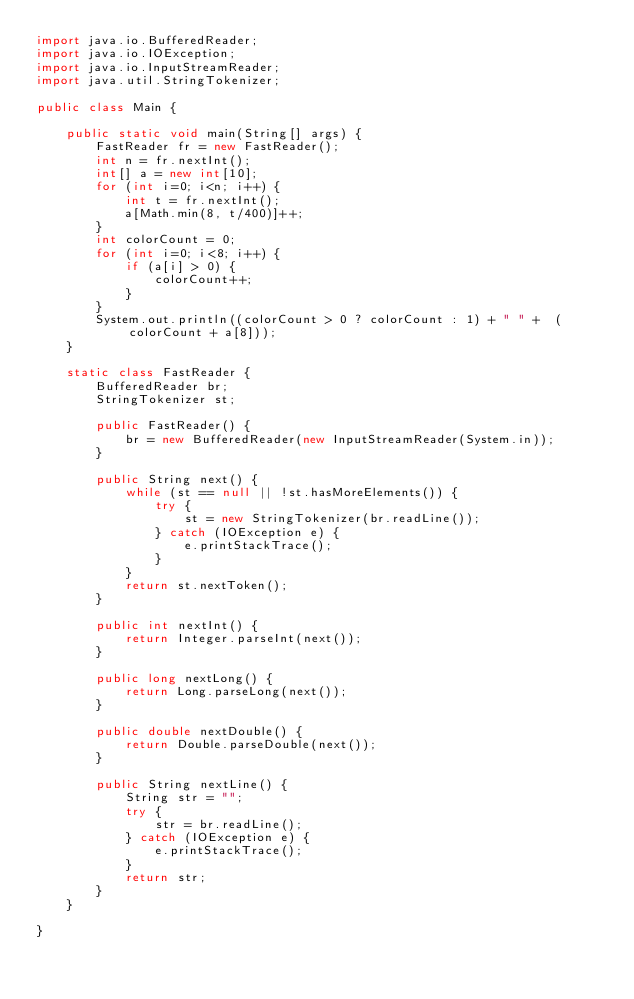<code> <loc_0><loc_0><loc_500><loc_500><_Java_>import java.io.BufferedReader;
import java.io.IOException;
import java.io.InputStreamReader;
import java.util.StringTokenizer;

public class Main {

	public static void main(String[] args) {
		FastReader fr = new FastReader();
		int n = fr.nextInt();
		int[] a = new int[10];
		for (int i=0; i<n; i++) {
			int t = fr.nextInt();
			a[Math.min(8, t/400)]++;
		}
		int colorCount = 0;
		for (int i=0; i<8; i++) {
			if (a[i] > 0) {
				colorCount++;
			}
		}
		System.out.println((colorCount > 0 ? colorCount : 1) + " " +  (colorCount + a[8]));
	}
	
	static class FastReader {
		BufferedReader br;
		StringTokenizer st;

		public FastReader() {
			br = new BufferedReader(new InputStreamReader(System.in));
		}

		public String next() {
			while (st == null || !st.hasMoreElements()) {
				try {
					st = new StringTokenizer(br.readLine());
				} catch (IOException e) {
					e.printStackTrace();
				}
			}
			return st.nextToken();
		}

		public int nextInt() {
			return Integer.parseInt(next());
		}

		public long nextLong() {
			return Long.parseLong(next());
		}

		public double nextDouble() {
			return Double.parseDouble(next());
		}

		public String nextLine() {
			String str = "";
			try {
				str = br.readLine();
			} catch (IOException e) {
				e.printStackTrace();
			}
			return str;
		}
	}

}
</code> 